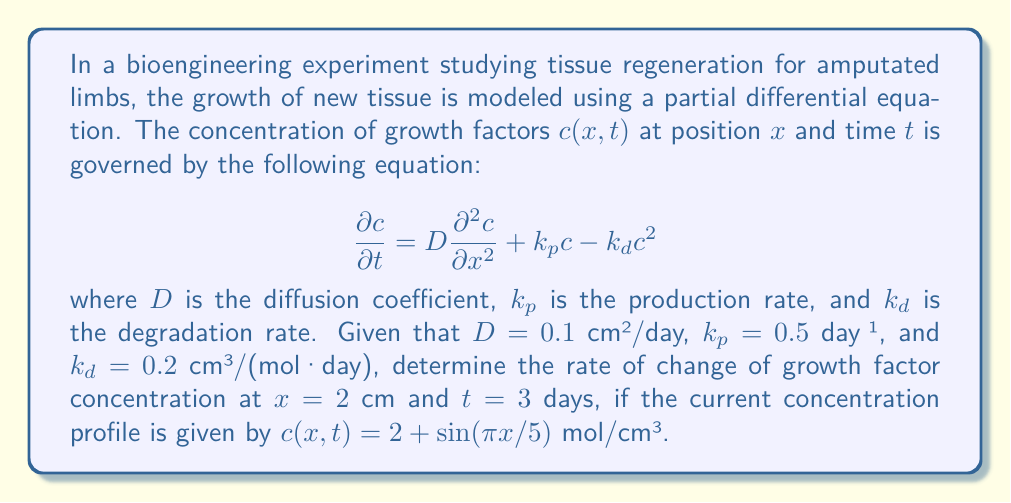Can you answer this question? To solve this problem, we need to evaluate the partial differential equation at the given point and time using the provided concentration profile. Let's break it down step by step:

1) We are given the PDE:
   $$\frac{\partial c}{\partial t} = D\frac{\partial^2 c}{\partial x^2} + k_p c - k_d c^2$$

2) We need to calculate each term separately and then combine them:

   a) First term: $D\frac{\partial^2 c}{\partial x^2}$
      The concentration profile is $c(x,t) = 2 + \sin(πx/5)$
      $$\frac{\partial c}{\partial x} = \frac{π}{5}\cos(πx/5)$$
      $$\frac{\partial^2 c}{\partial x^2} = -\frac{π^2}{25}\sin(πx/5)$$
      At $x = 2$: 
      $$\frac{\partial^2 c}{\partial x^2} = -\frac{π^2}{25}\sin(2π/5)$$
      Therefore, $D\frac{\partial^2 c}{\partial x^2} = 0.1 \cdot (-\frac{π^2}{25}\sin(2π/5))$

   b) Second term: $k_p c$
      At $x = 2$: $c = 2 + \sin(2π/5)$
      Therefore, $k_p c = 0.5 \cdot (2 + \sin(2π/5))$

   c) Third term: $-k_d c^2$
      At $x = 2$: $c = 2 + \sin(2π/5)$
      Therefore, $-k_d c^2 = -0.2 \cdot (2 + \sin(2π/5))^2$

3) Now, we can combine all terms:

   $$\frac{\partial c}{\partial t} = 0.1 \cdot (-\frac{π^2}{25}\sin(2π/5)) + 0.5 \cdot (2 + \sin(2π/5)) - 0.2 \cdot (2 + \sin(2π/5))^2$$

4) Evaluating this expression:
   $$\frac{\partial c}{\partial t} ≈ -0.0776 + 1.2902 - 0.8376 = 0.3750$$ mol/(cm³·day)
Answer: The rate of change of growth factor concentration at $x = 2$ cm and $t = 3$ days is approximately 0.3750 mol/(cm³·day). 